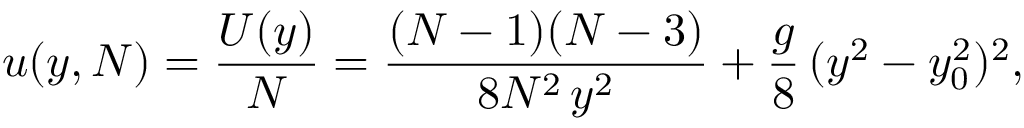Convert formula to latex. <formula><loc_0><loc_0><loc_500><loc_500>u ( y , N ) = \frac { U ( y ) } { N } = \frac { ( N - 1 ) ( N - 3 ) } { 8 N ^ { 2 } \, y ^ { 2 } } + \frac { g } { 8 } \, ( y ^ { 2 } - y _ { 0 } ^ { 2 } ) ^ { 2 } ,</formula> 